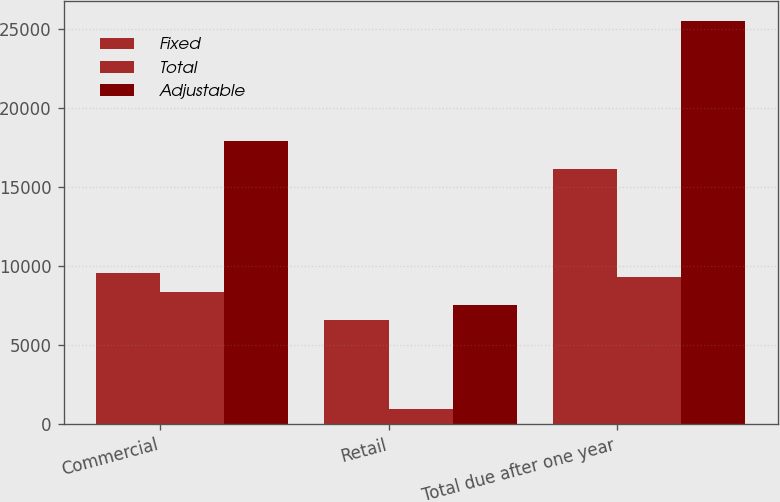Convert chart to OTSL. <chart><loc_0><loc_0><loc_500><loc_500><stacked_bar_chart><ecel><fcel>Commercial<fcel>Retail<fcel>Total due after one year<nl><fcel>Fixed<fcel>9568<fcel>6587.6<fcel>16155.6<nl><fcel>Total<fcel>8362.8<fcel>982.8<fcel>9345.6<nl><fcel>Adjustable<fcel>17930.8<fcel>7570.4<fcel>25501.2<nl></chart> 